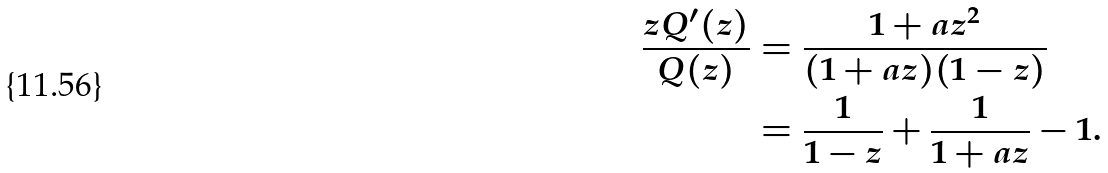<formula> <loc_0><loc_0><loc_500><loc_500>\frac { z Q ^ { \prime } ( z ) } { Q ( z ) } & = \frac { 1 + a z ^ { 2 } } { ( 1 + a z ) ( 1 - z ) } \\ & = \frac { 1 } { 1 - z } + \frac { 1 } { 1 + a z } - 1 .</formula> 